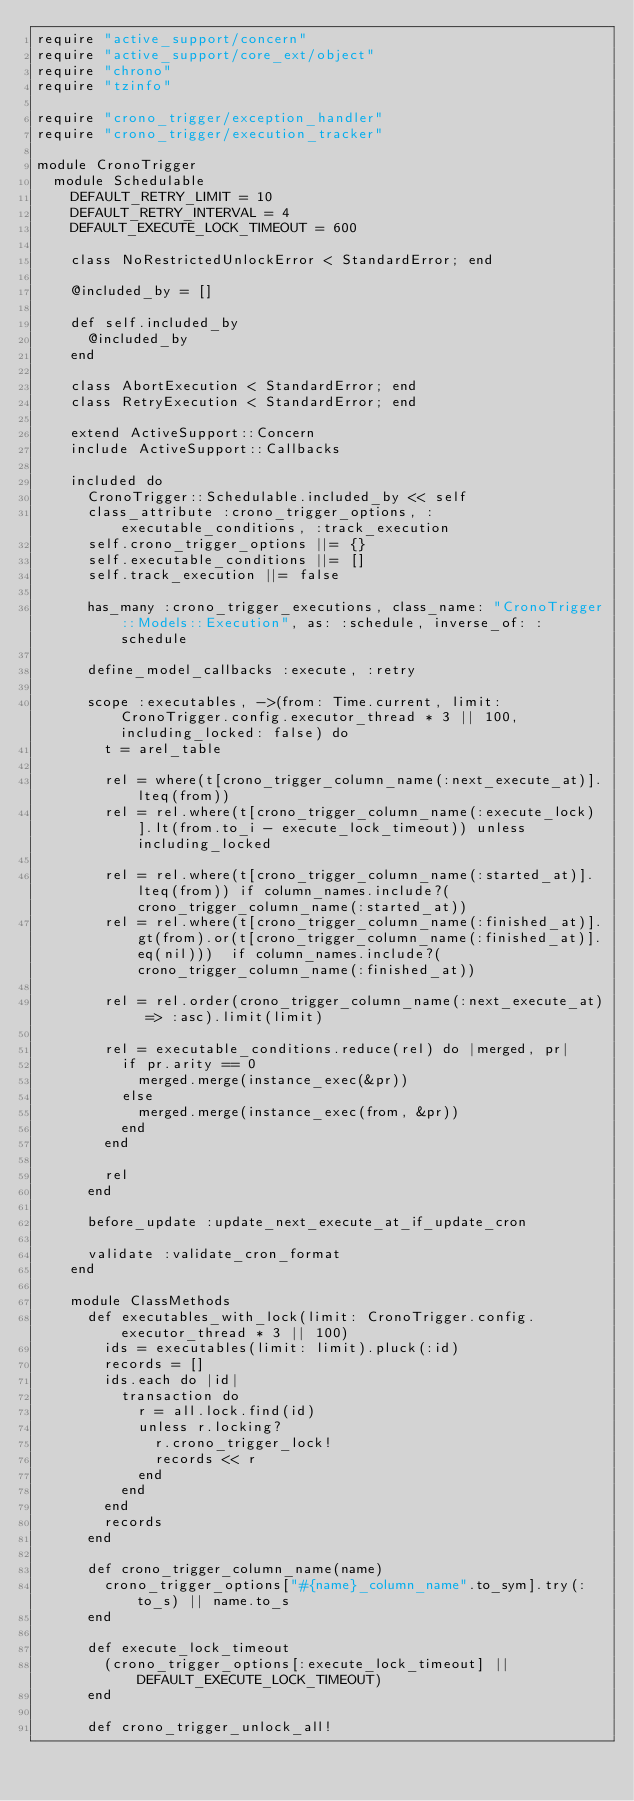Convert code to text. <code><loc_0><loc_0><loc_500><loc_500><_Ruby_>require "active_support/concern"
require "active_support/core_ext/object"
require "chrono"
require "tzinfo"

require "crono_trigger/exception_handler"
require "crono_trigger/execution_tracker"

module CronoTrigger
  module Schedulable
    DEFAULT_RETRY_LIMIT = 10
    DEFAULT_RETRY_INTERVAL = 4
    DEFAULT_EXECUTE_LOCK_TIMEOUT = 600

    class NoRestrictedUnlockError < StandardError; end

    @included_by = []

    def self.included_by
      @included_by
    end

    class AbortExecution < StandardError; end
    class RetryExecution < StandardError; end

    extend ActiveSupport::Concern
    include ActiveSupport::Callbacks

    included do
      CronoTrigger::Schedulable.included_by << self
      class_attribute :crono_trigger_options, :executable_conditions, :track_execution
      self.crono_trigger_options ||= {}
      self.executable_conditions ||= []
      self.track_execution ||= false

      has_many :crono_trigger_executions, class_name: "CronoTrigger::Models::Execution", as: :schedule, inverse_of: :schedule

      define_model_callbacks :execute, :retry

      scope :executables, ->(from: Time.current, limit: CronoTrigger.config.executor_thread * 3 || 100, including_locked: false) do
        t = arel_table

        rel = where(t[crono_trigger_column_name(:next_execute_at)].lteq(from))
        rel = rel.where(t[crono_trigger_column_name(:execute_lock)].lt(from.to_i - execute_lock_timeout)) unless including_locked

        rel = rel.where(t[crono_trigger_column_name(:started_at)].lteq(from)) if column_names.include?(crono_trigger_column_name(:started_at))
        rel = rel.where(t[crono_trigger_column_name(:finished_at)].gt(from).or(t[crono_trigger_column_name(:finished_at)].eq(nil)))  if column_names.include?(crono_trigger_column_name(:finished_at))

        rel = rel.order(crono_trigger_column_name(:next_execute_at) => :asc).limit(limit)

        rel = executable_conditions.reduce(rel) do |merged, pr|
          if pr.arity == 0
            merged.merge(instance_exec(&pr))
          else
            merged.merge(instance_exec(from, &pr))
          end
        end

        rel
      end

      before_update :update_next_execute_at_if_update_cron

      validate :validate_cron_format
    end

    module ClassMethods
      def executables_with_lock(limit: CronoTrigger.config.executor_thread * 3 || 100)
        ids = executables(limit: limit).pluck(:id)
        records = []
        ids.each do |id|
          transaction do
            r = all.lock.find(id)
            unless r.locking?
              r.crono_trigger_lock!
              records << r
            end
          end
        end
        records
      end

      def crono_trigger_column_name(name)
        crono_trigger_options["#{name}_column_name".to_sym].try(:to_s) || name.to_s
      end

      def execute_lock_timeout
        (crono_trigger_options[:execute_lock_timeout] || DEFAULT_EXECUTE_LOCK_TIMEOUT)
      end

      def crono_trigger_unlock_all!</code> 